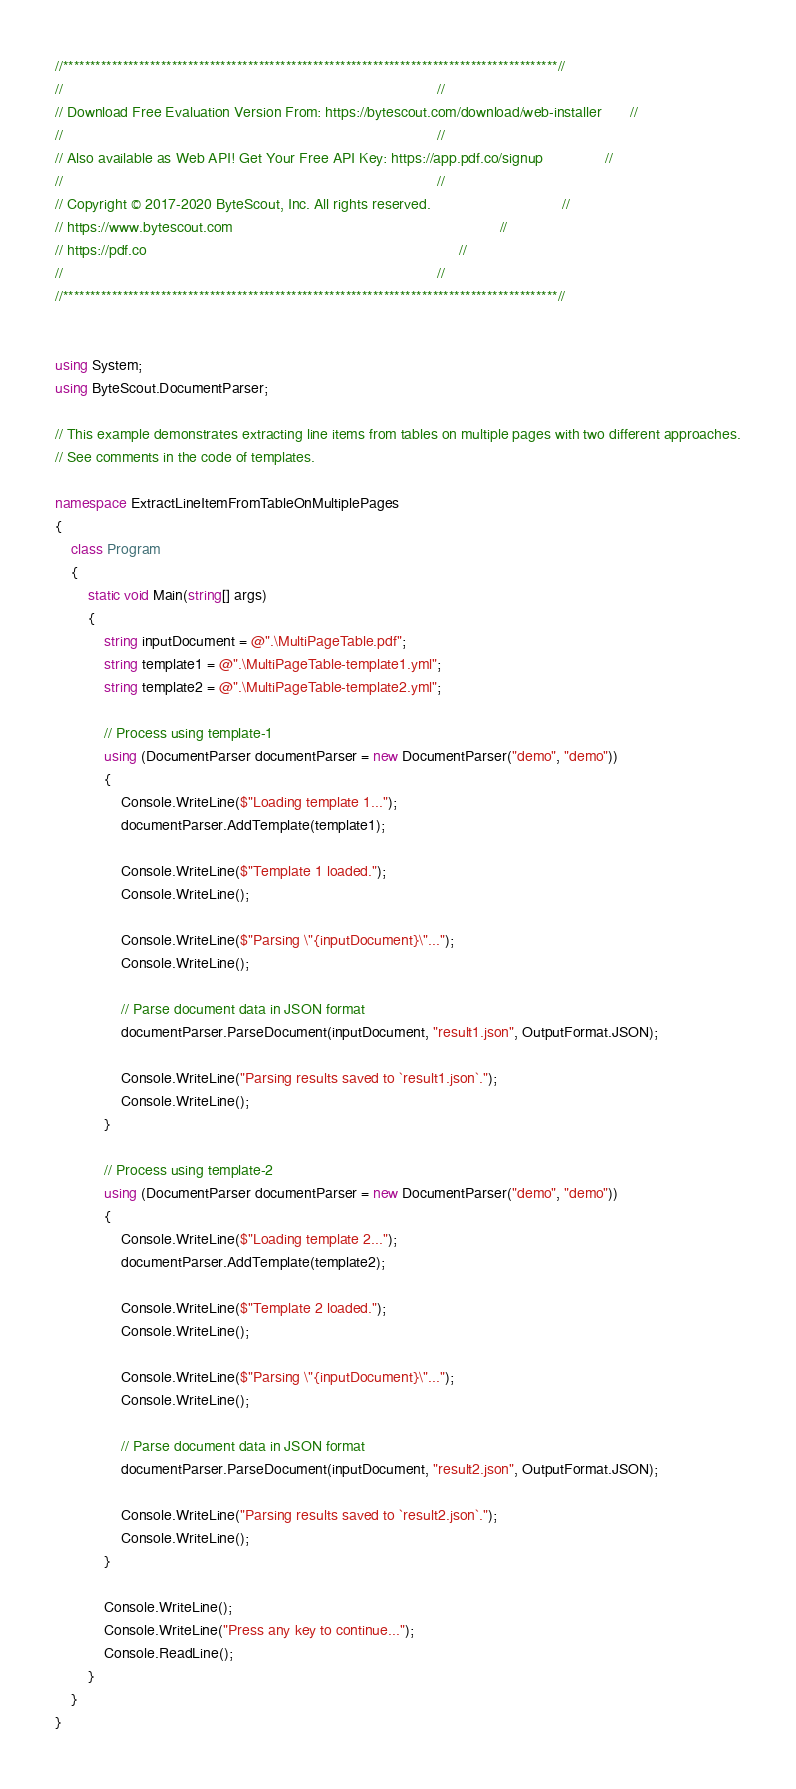<code> <loc_0><loc_0><loc_500><loc_500><_C#_>//*******************************************************************************************//
//                                                                                           //
// Download Free Evaluation Version From: https://bytescout.com/download/web-installer       //
//                                                                                           //
// Also available as Web API! Get Your Free API Key: https://app.pdf.co/signup               //
//                                                                                           //
// Copyright © 2017-2020 ByteScout, Inc. All rights reserved.                                //
// https://www.bytescout.com                                                                 //
// https://pdf.co                                                                            //
//                                                                                           //
//*******************************************************************************************//


using System;
using ByteScout.DocumentParser;

// This example demonstrates extracting line items from tables on multiple pages with two different approaches.
// See comments in the code of templates.

namespace ExtractLineItemFromTableOnMultiplePages
{
    class Program
    {
        static void Main(string[] args)
        {
            string inputDocument = @".\MultiPageTable.pdf";
            string template1 = @".\MultiPageTable-template1.yml";
            string template2 = @".\MultiPageTable-template2.yml";

            // Process using template-1
            using (DocumentParser documentParser = new DocumentParser("demo", "demo"))
            {
                Console.WriteLine($"Loading template 1...");
                documentParser.AddTemplate(template1);

                Console.WriteLine($"Template 1 loaded.");
                Console.WriteLine();

                Console.WriteLine($"Parsing \"{inputDocument}\"...");
                Console.WriteLine();

                // Parse document data in JSON format
                documentParser.ParseDocument(inputDocument, "result1.json", OutputFormat.JSON);

                Console.WriteLine("Parsing results saved to `result1.json`.");
                Console.WriteLine();
            }

            // Process using template-2
            using (DocumentParser documentParser = new DocumentParser("demo", "demo"))
            {
                Console.WriteLine($"Loading template 2...");
                documentParser.AddTemplate(template2);

                Console.WriteLine($"Template 2 loaded.");
                Console.WriteLine();

                Console.WriteLine($"Parsing \"{inputDocument}\"...");
                Console.WriteLine();

                // Parse document data in JSON format
                documentParser.ParseDocument(inputDocument, "result2.json", OutputFormat.JSON);

                Console.WriteLine("Parsing results saved to `result2.json`.");
                Console.WriteLine();
            }

            Console.WriteLine();
            Console.WriteLine("Press any key to continue...");
            Console.ReadLine();
        }
    }
}
</code> 